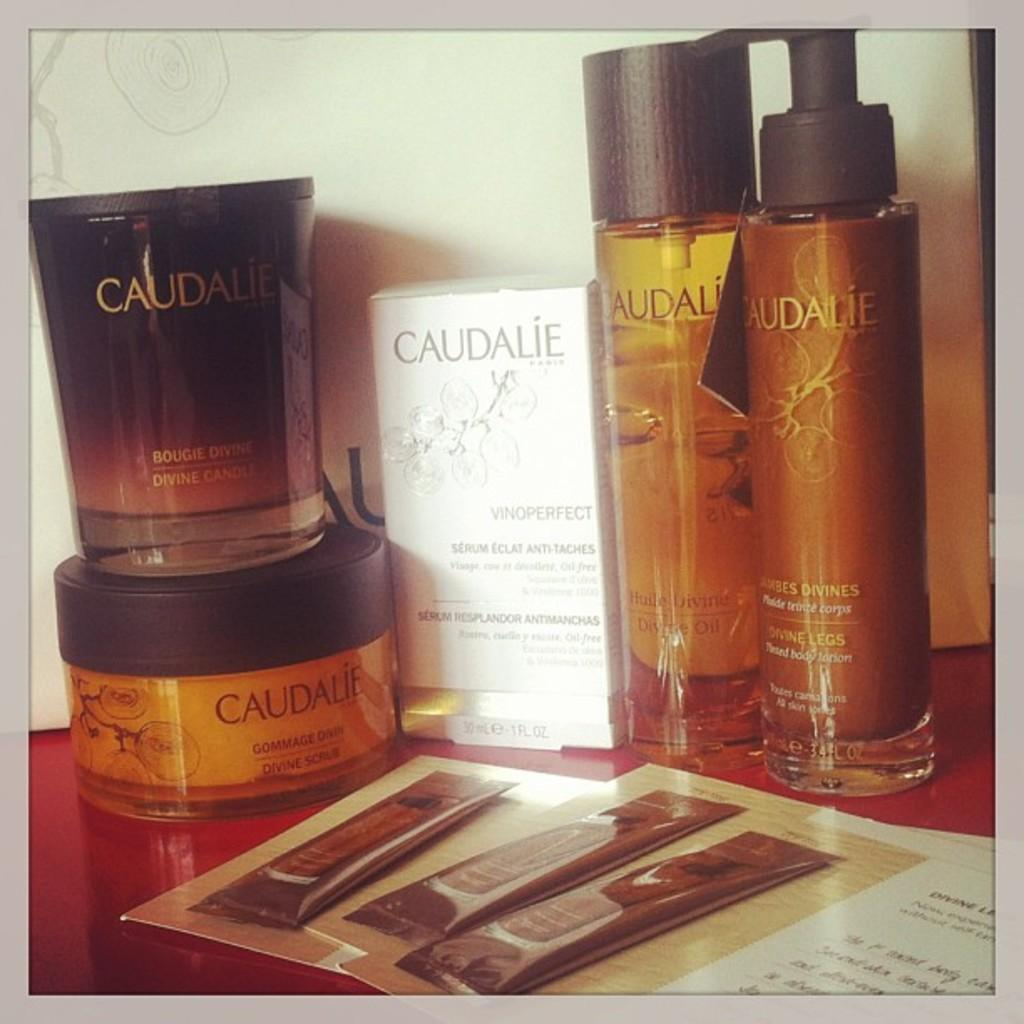<image>
Render a clear and concise summary of the photo. Bottle of Caudalie next to a white box of Caudalie. 